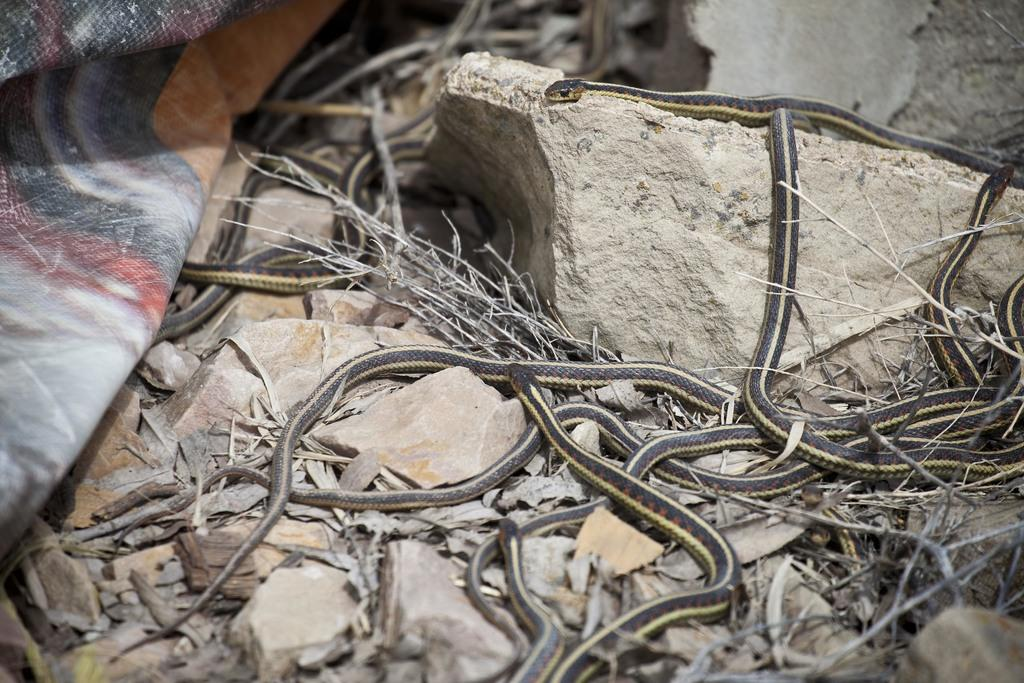What type of animals can be seen in the image? There are snakes in the image. Where are the snakes located? The snakes are all over the ground in the image. What else can be seen on the ground in the image? There are rocks in the image. What type of observation can be made about the jail in the image? There is no jail present in the image; it features snakes and rocks on the ground. 